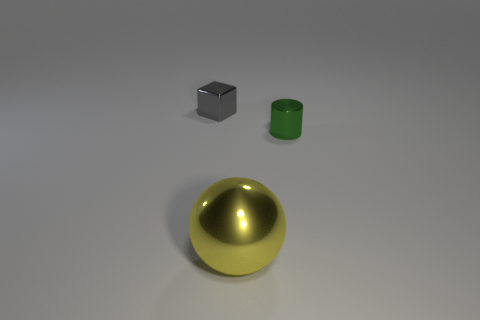Are there any other things that have the same shape as the big yellow object?
Your answer should be compact. No. Is there any other thing that is the same size as the yellow metal object?
Ensure brevity in your answer.  No. Is the color of the large shiny thing the same as the tiny thing left of the metallic sphere?
Offer a terse response. No. How many metal things are to the left of the big thing?
Ensure brevity in your answer.  1. Are there fewer large brown things than gray cubes?
Provide a short and direct response. Yes. What size is the metallic object that is both left of the tiny metal cylinder and right of the gray shiny block?
Your response must be concise. Large. There is a tiny object to the right of the gray block; is it the same color as the metallic sphere?
Your answer should be compact. No. Is the number of gray cubes right of the yellow thing less than the number of metallic spheres?
Keep it short and to the point. Yes. What is the shape of the green thing that is the same material as the large sphere?
Your response must be concise. Cylinder. Is the big yellow sphere made of the same material as the gray block?
Keep it short and to the point. Yes. 